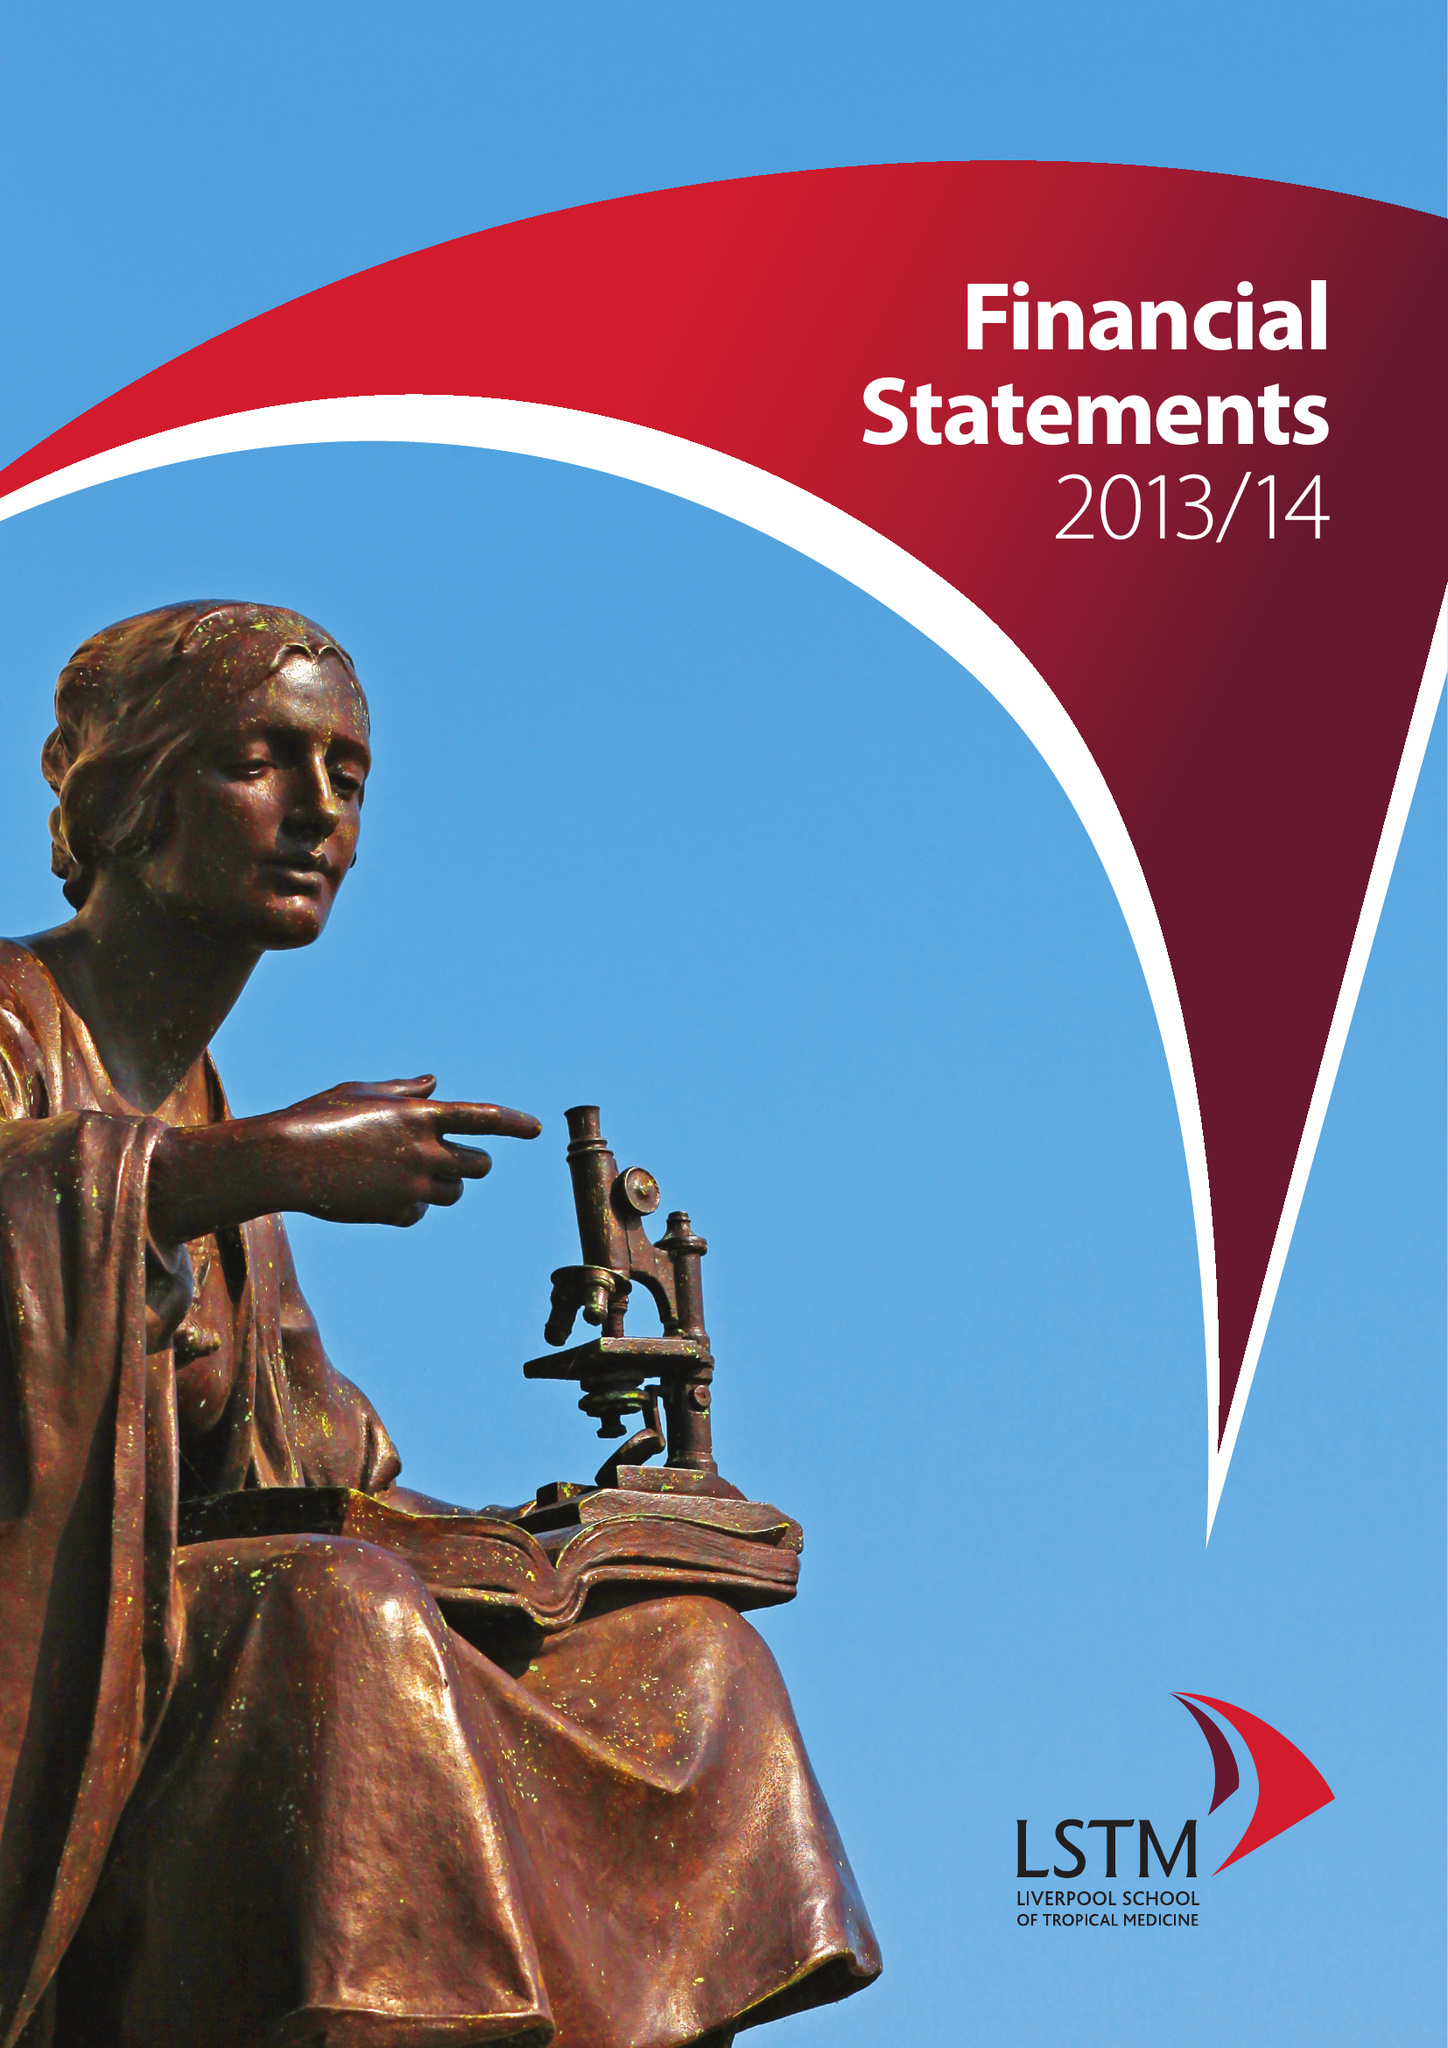What is the value for the address__street_line?
Answer the question using a single word or phrase. PEMBROKE PLACE 